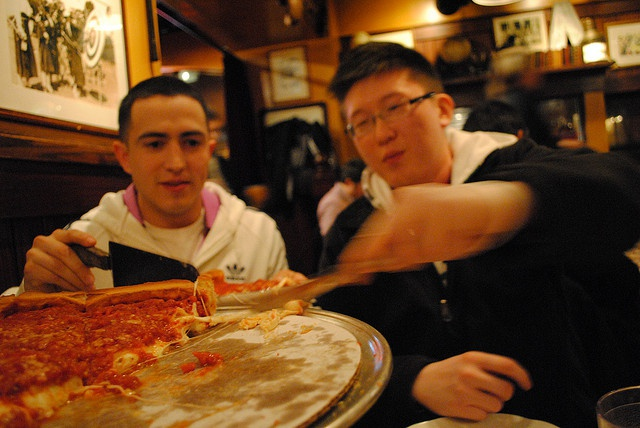Describe the objects in this image and their specific colors. I can see people in tan, black, brown, and maroon tones, people in tan, brown, maroon, and black tones, pizza in tan, maroon, and red tones, knife in tan, black, maroon, and olive tones, and people in tan, black, maroon, and olive tones in this image. 